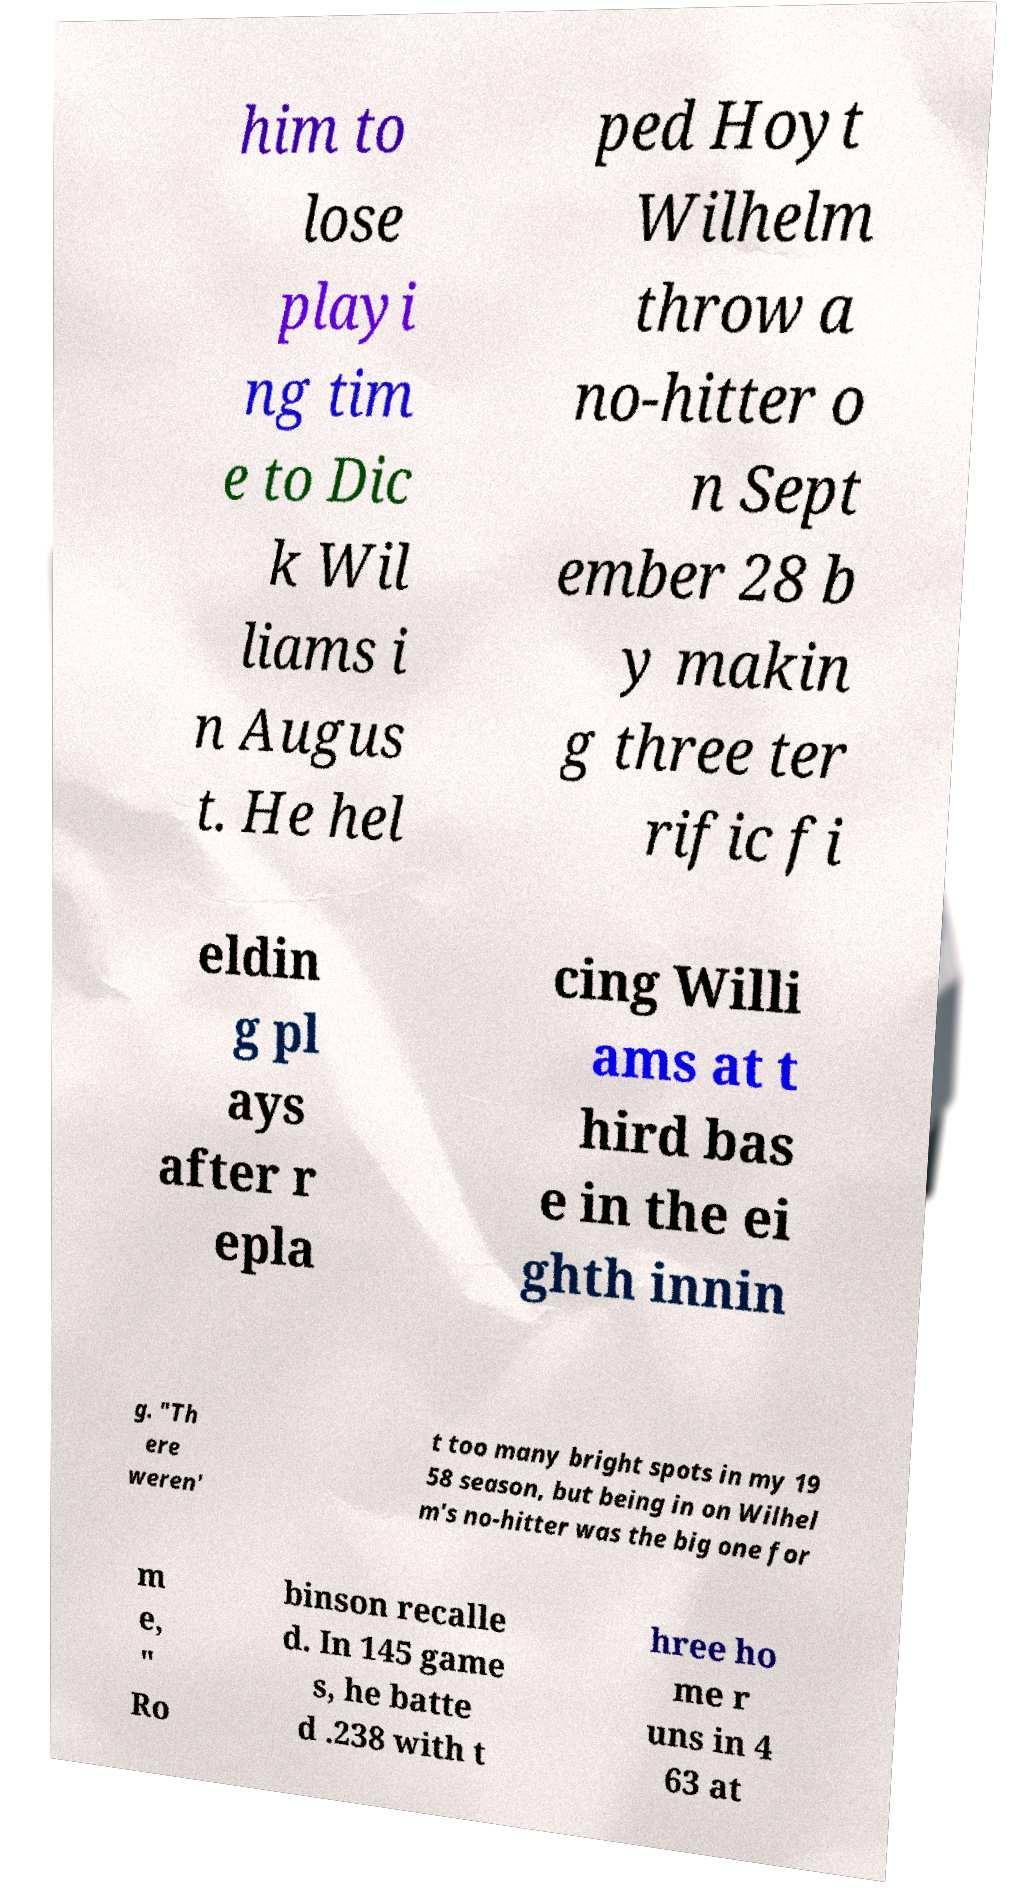Can you accurately transcribe the text from the provided image for me? him to lose playi ng tim e to Dic k Wil liams i n Augus t. He hel ped Hoyt Wilhelm throw a no-hitter o n Sept ember 28 b y makin g three ter rific fi eldin g pl ays after r epla cing Willi ams at t hird bas e in the ei ghth innin g. "Th ere weren' t too many bright spots in my 19 58 season, but being in on Wilhel m's no-hitter was the big one for m e, " Ro binson recalle d. In 145 game s, he batte d .238 with t hree ho me r uns in 4 63 at 